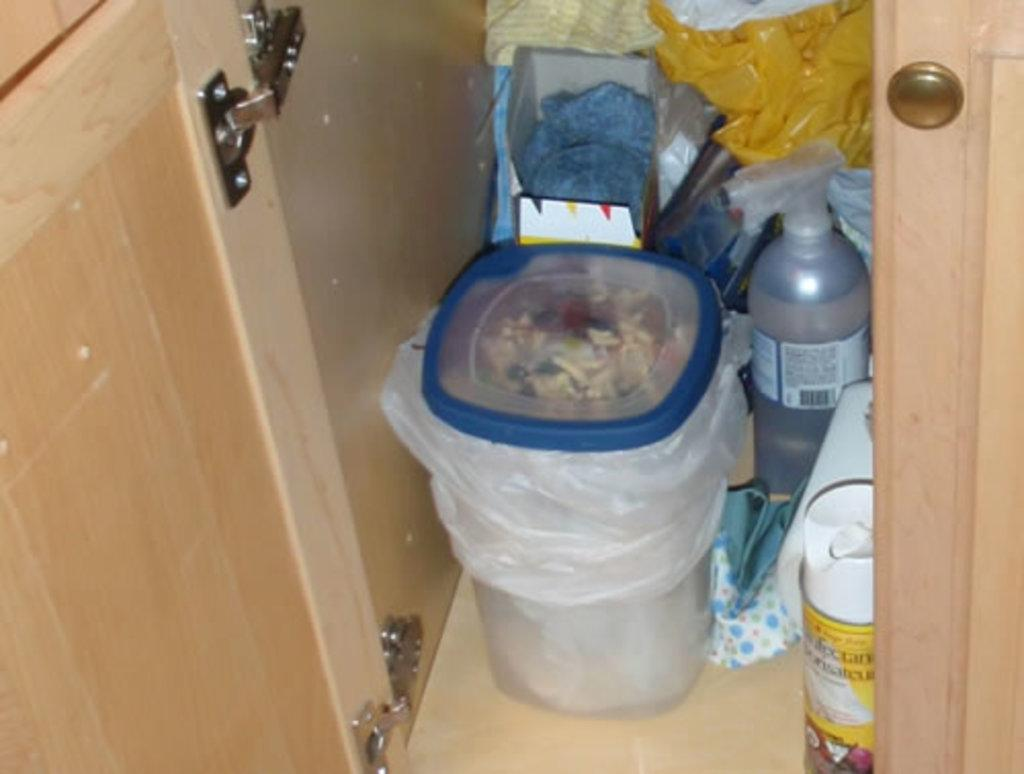What type of space is depicted in the image? The image is of a room. What is one feature of the room that allows for entry and exit? There is a door in the room. What is used for waste disposal in the room? There is a bin with trash in the room. What type of container is present in the room? There is a bottle in the room. What is used to cover or protect something in the room? There is a plastic cover in the room. What type of storage container is present in the room? There is a box in the room. How many brothers are playing with the tramp in the room? There is no tramp or brothers present in the image; it is a room with various objects and no people. What type of material is the rub used for in the room? There is no rub or specific material mentioned in the image; it only contains a room with various objects. 